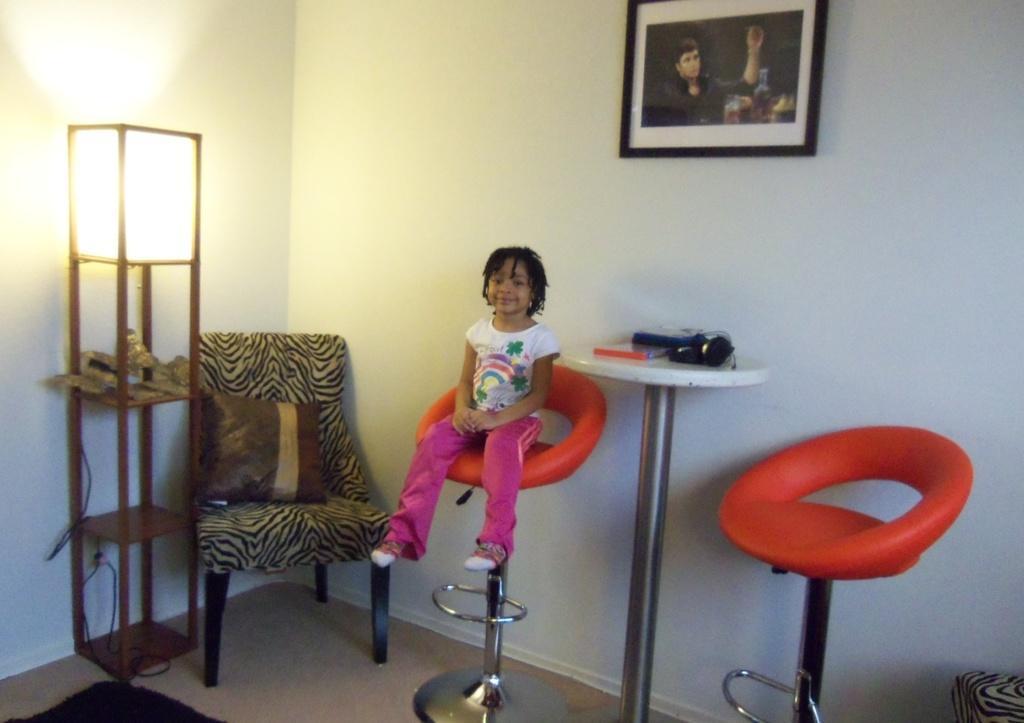Could you give a brief overview of what you see in this image? In this image there is a little girl sitting in a chair. At the background there is a wall and a photo frame on it. To the left side there is a light and a chair with a pillow on it,beside the child there is a table on which there are things. 